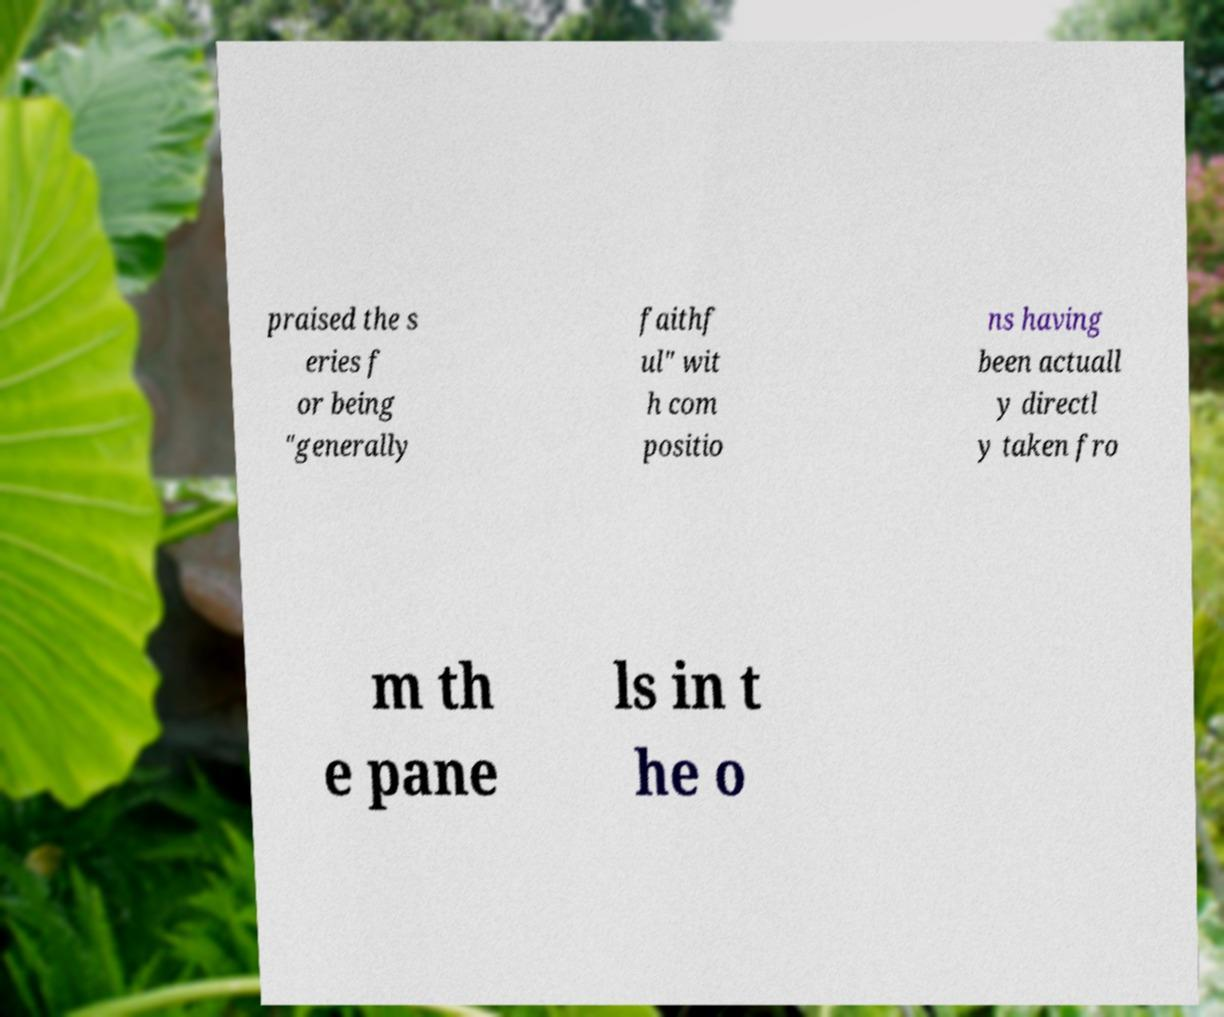What messages or text are displayed in this image? I need them in a readable, typed format. praised the s eries f or being "generally faithf ul" wit h com positio ns having been actuall y directl y taken fro m th e pane ls in t he o 